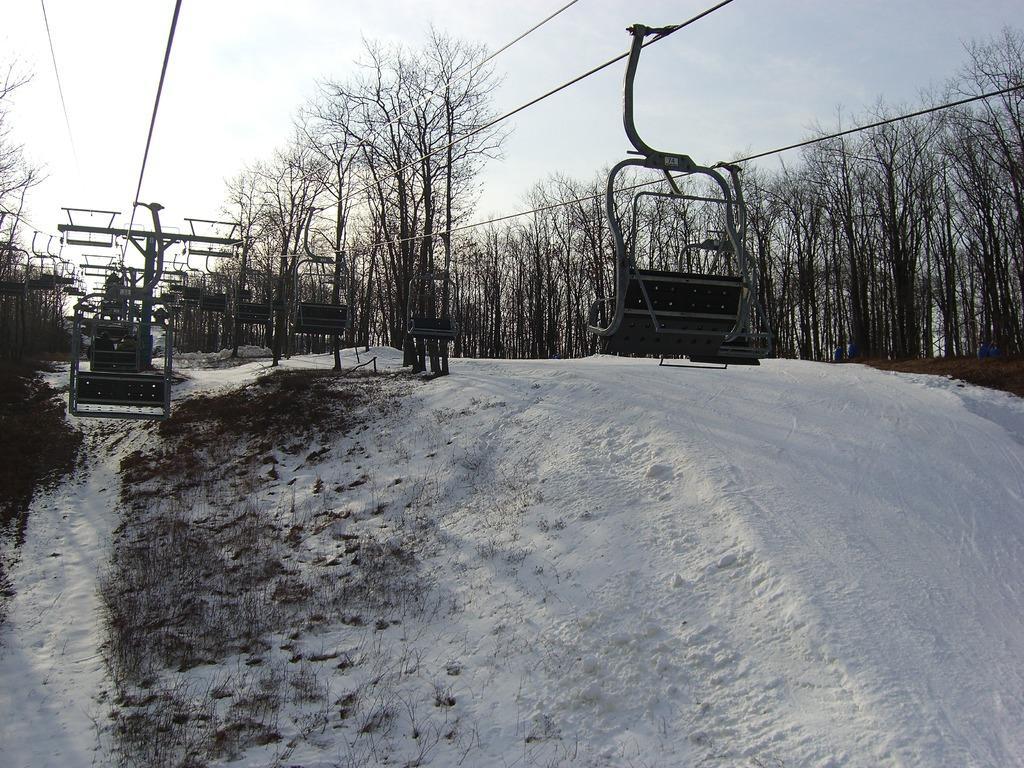Describe this image in one or two sentences. In this image we can see some trees, snow, grass and the ropeways, also we can see the sky. 